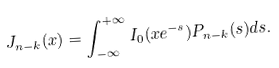Convert formula to latex. <formula><loc_0><loc_0><loc_500><loc_500>J _ { n - k } ( x ) = \int _ { - \infty } ^ { + \infty } I _ { 0 } ( x e ^ { - s } ) P _ { n - k } ( s ) d s .</formula> 